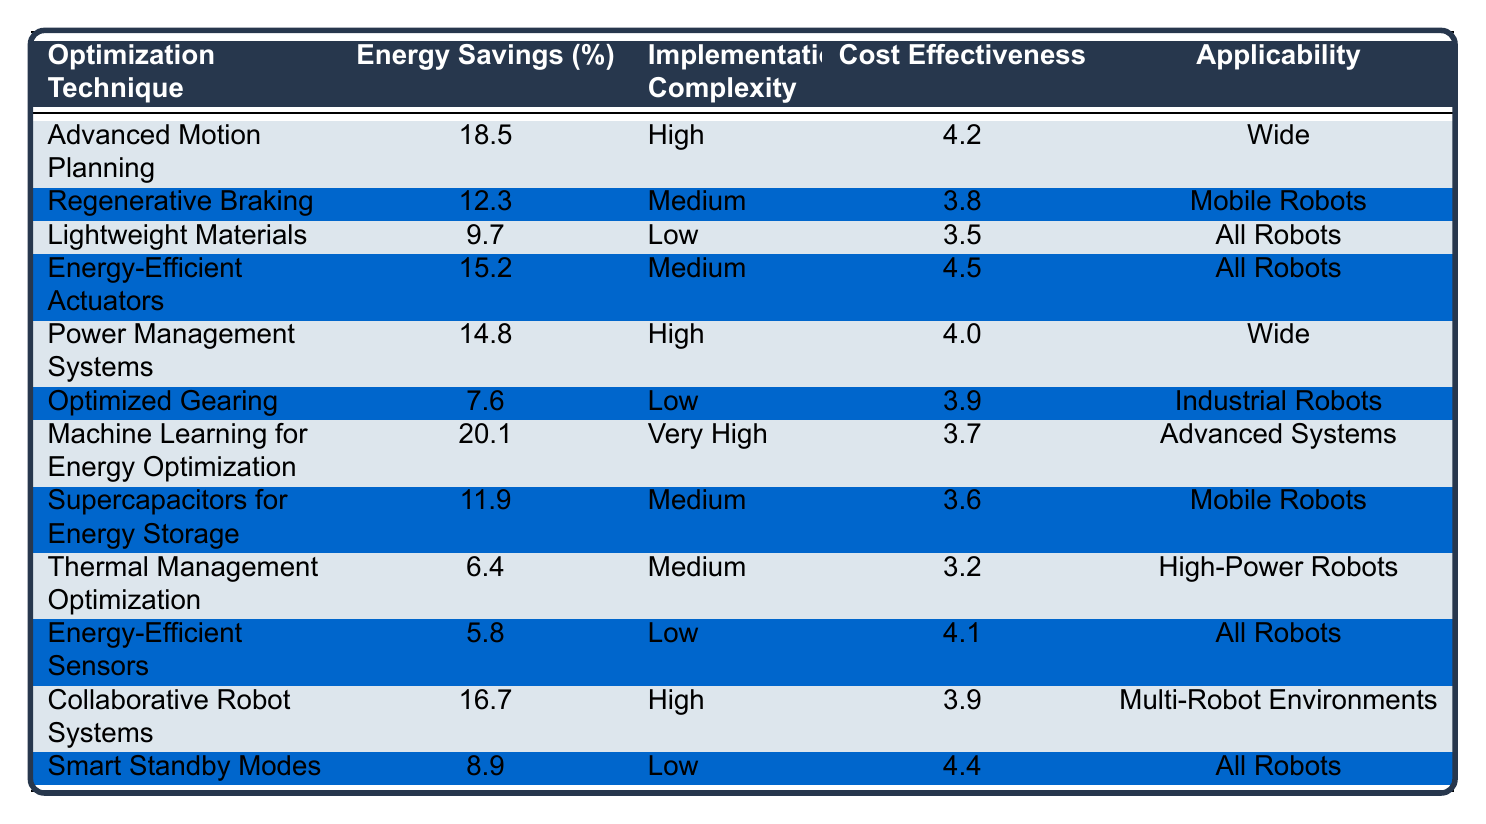What is the optimization technique with the highest energy savings? The table lists various optimization techniques and their corresponding energy savings percentages. Scanning through the 'Energy Savings (%)' column, 'Machine Learning for Energy Optimization' with a value of 20.1% has the highest savings.
Answer: Machine Learning for Energy Optimization Which optimization techniques have low implementation complexity? By reviewing the 'Implementation Complexity' column, the techniques marked as 'Low' are 'Lightweight Materials', 'Optimized Gearing', 'Energy-Efficient Sensors', and 'Smart Standby Modes'.
Answer: Lightweight Materials, Optimized Gearing, Energy-Efficient Sensors, Smart Standby Modes Calculate the average energy savings of the techniques applicable to all robots. The techniques applicable to all robots are 'Lightweight Materials', 'Energy-Efficient Actuators', 'Energy-Efficient Sensors', and 'Smart Standby Modes'. Their energy savings percentages are 9.7, 15.2, 5.8, and 8.9 respectively. The total is 9.7 + 15.2 + 5.8 + 8.9 = 39.6. There are 4 techniques, so the average is 39.6 / 4 = 9.9%.
Answer: 9.9% Is 'Regenerative Braking' more energy-efficient than 'Optimized Gearing'? Comparing the energy savings of 'Regenerative Braking' (12.3%) and 'Optimized Gearing' (7.6%), 'Regenerative Braking' has a higher percentage, confirming that it is more energy-efficient.
Answer: Yes Which optimization technique has the highest cost effectiveness rating? The table indicates the cost effectiveness ratings, where 'Energy-Efficient Actuators' has the highest value of 4.5 among all techniques.
Answer: Energy-Efficient Actuators Do techniques with high implementation complexity generally have higher energy savings? Reviewing the techniques marked as 'High' for implementation complexity, namely 'Advanced Motion Planning' (18.5%) and 'Power Management Systems' (14.8%), both show that higher complexity correlates with significant energy savings.
Answer: Generally, Yes What is the total energy savings from techniques applicable to mobile robots? The applicable techniques are 'Regenerative Braking' (12.3%), 'Supercapacitors for Energy Storage' (11.9%). Their total savings is 12.3 + 11.9 = 24.2%.
Answer: 24.2% Which optimization technique is most commonly applicable to wide-ranging scenarios? By inspecting the 'Applicability' column, both 'Advanced Motion Planning' and 'Power Management Systems' are noted as 'Wide', making them the most commonly applicable in this scenario.
Answer: Advanced Motion Planning, Power Management Systems What is the difference in energy savings between the most and least effective techniques? The most energy-efficient technique is 'Machine Learning for Energy Optimization' at 20.1%, and the least effective is 'Energy-Efficient Sensors' at 5.8%. The difference is 20.1 - 5.8 = 14.3%.
Answer: 14.3% Are there any optimization techniques with very high implementation complexity that are not designed for advanced systems? The only technique marked as 'Very High' for implementation complexity is 'Machine Learning for Energy Optimization', which is also mentioned as applicable only to 'Advanced Systems'. Therefore, there are no such techniques.
Answer: No 